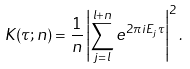Convert formula to latex. <formula><loc_0><loc_0><loc_500><loc_500>K ( \tau ; n ) = \frac { 1 } { n } \left | \sum _ { j = l } ^ { l + n } e ^ { 2 \pi i E _ { j } \tau } \right | ^ { 2 } .</formula> 